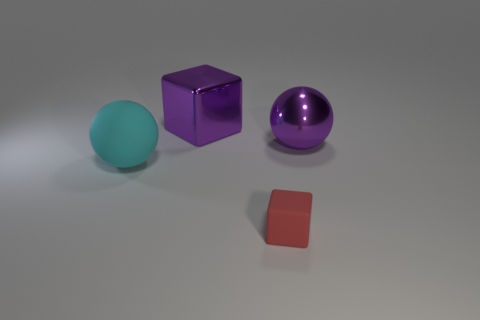Are there any other things that are the same size as the red object?
Provide a succinct answer. No. Do the rubber thing left of the purple block and the block behind the small object have the same size?
Provide a short and direct response. Yes. How big is the purple object to the right of the tiny red thing?
Your response must be concise. Large. Is there a small block that has the same color as the large shiny sphere?
Your answer should be very brief. No. Are there any purple objects that are on the left side of the sphere that is behind the big cyan rubber object?
Provide a succinct answer. Yes. There is a shiny block; is its size the same as the purple metallic object to the right of the red cube?
Your answer should be compact. Yes. Is there a large purple thing that is in front of the cube to the right of the cube that is behind the large cyan sphere?
Make the answer very short. No. What is the material of the object right of the red matte thing?
Give a very brief answer. Metal. Is the size of the matte block the same as the shiny ball?
Ensure brevity in your answer.  No. There is a thing that is both behind the cyan rubber ball and on the right side of the purple block; what is its color?
Offer a very short reply. Purple. 